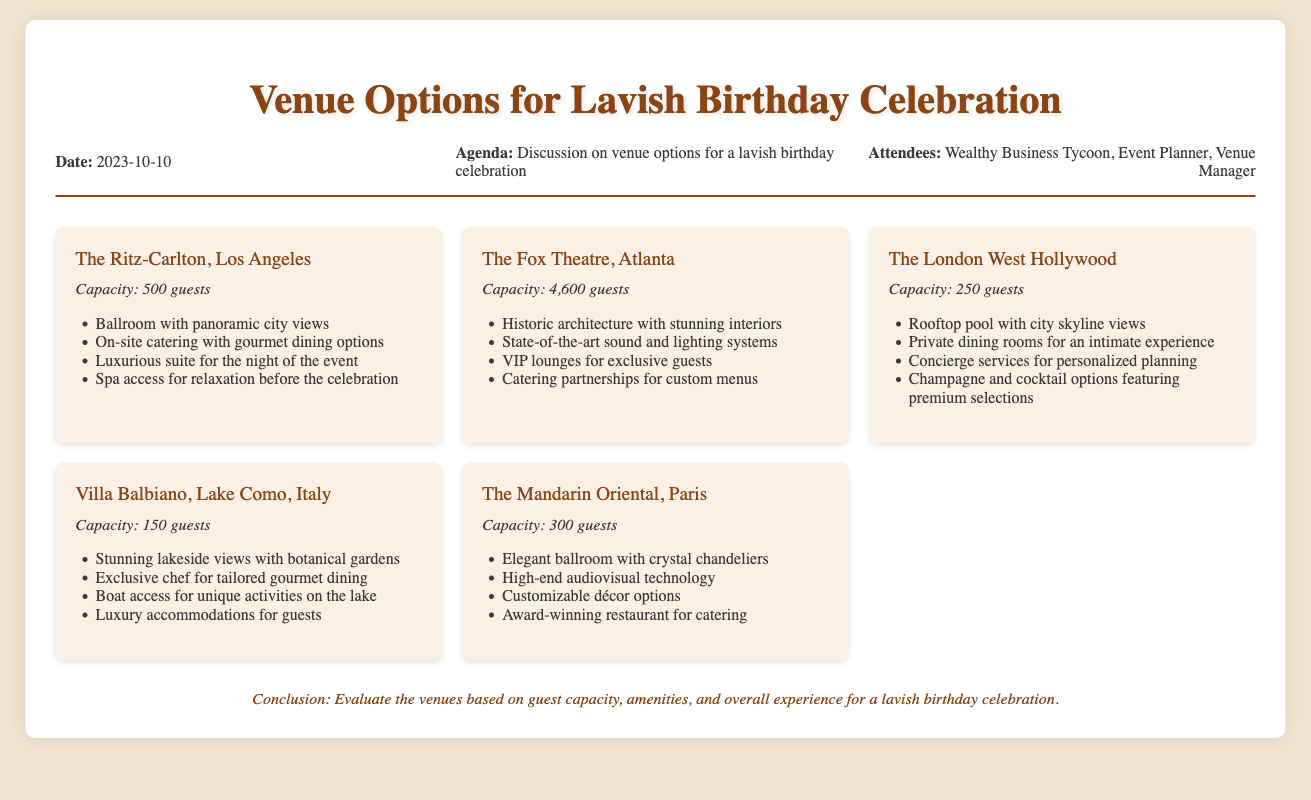What is the capacity of The Ritz-Carlton, Los Angeles? The capacity of The Ritz-Carlton, Los Angeles is stated in the document as 500 guests.
Answer: 500 guests What unique feature distinguishes The Fox Theatre, Atlanta? The document specifically mentions its historic architecture with stunning interiors as a distinguishing feature.
Answer: Historic architecture with stunning interiors How many guests can Villa Balbiano host? The document provides the guest capacity for Villa Balbiano as 150 guests.
Answer: 150 guests Which venue offers luxury accommodations for guests? The document lists Villa Balbiano as providing luxury accommodations for guests.
Answer: Villa Balbiano What amenity is available at The London West Hollywood? The document notes that The London West Hollywood has a rooftop pool with city skyline views.
Answer: Rooftop pool with city skyline views How does the capacity of The Mandarin Oriental compare to The London West Hollywood? The Mandarin Oriental has a capacity of 300 guests, which is greater than The London West Hollywood's 250 guests.
Answer: Greater What kind of dining options does The Ritz-Carlton provide? The document states that The Ritz-Carlton offers on-site catering with gourmet dining options.
Answer: Gourmet dining options What unique activity access is offered by Villa Balbiano? According to the document, Villa Balbiano provides boat access for unique activities on the lake.
Answer: Boat access for unique activities on the lake What is the date of the meeting regarding venue options? The document clearly lists the date of the meeting as October 10, 2023.
Answer: October 10, 2023 